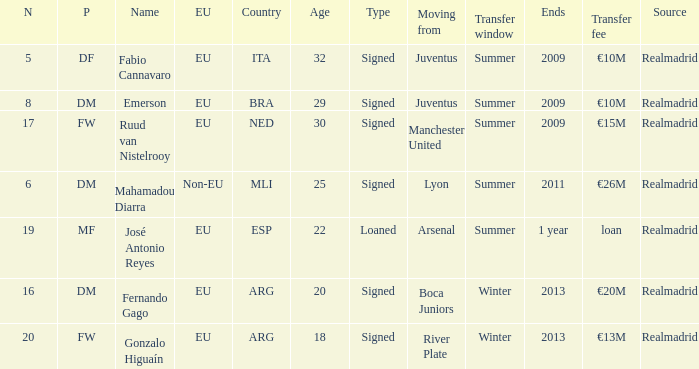What is the european union status of esp? EU. 